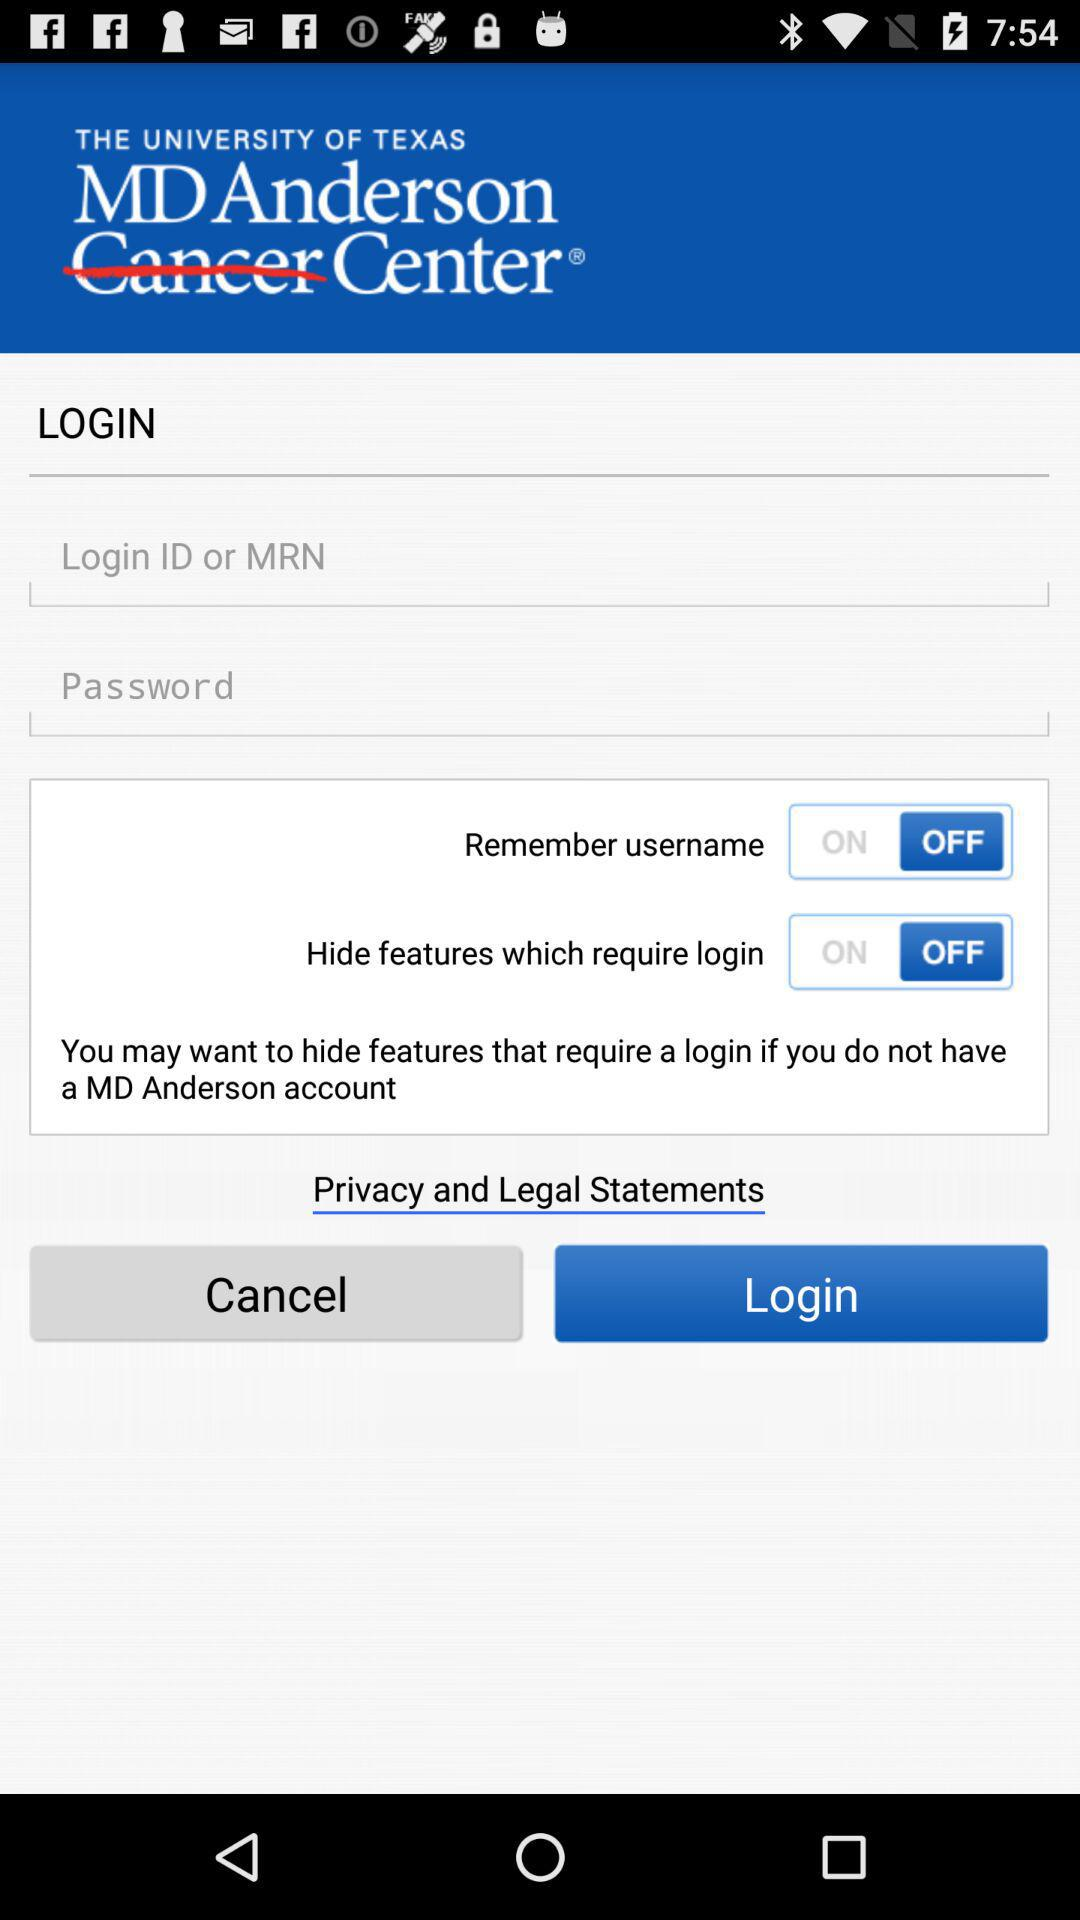What is the application name? The application name is "MD Anderson". 